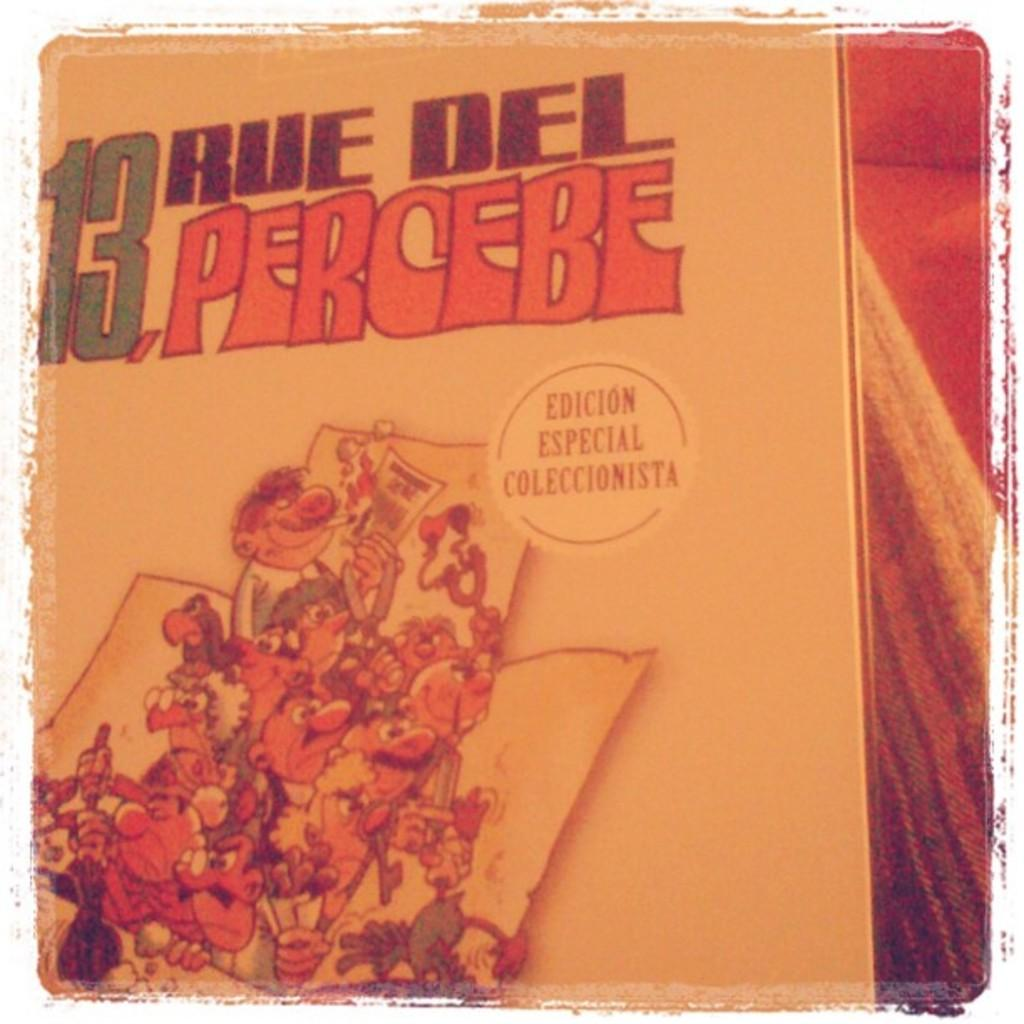<image>
Give a short and clear explanation of the subsequent image. A cartoon print of men coming out of a box with a Edicion Especial Coleccionista stick. 